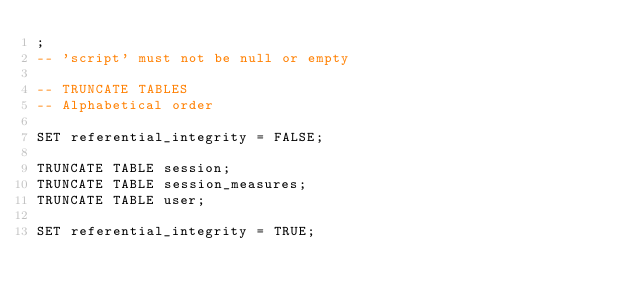<code> <loc_0><loc_0><loc_500><loc_500><_SQL_>;
-- 'script' must not be null or empty

-- TRUNCATE TABLES
-- Alphabetical order

SET referential_integrity = FALSE;

TRUNCATE TABLE session;
TRUNCATE TABLE session_measures;
TRUNCATE TABLE user;

SET referential_integrity = TRUE;
</code> 